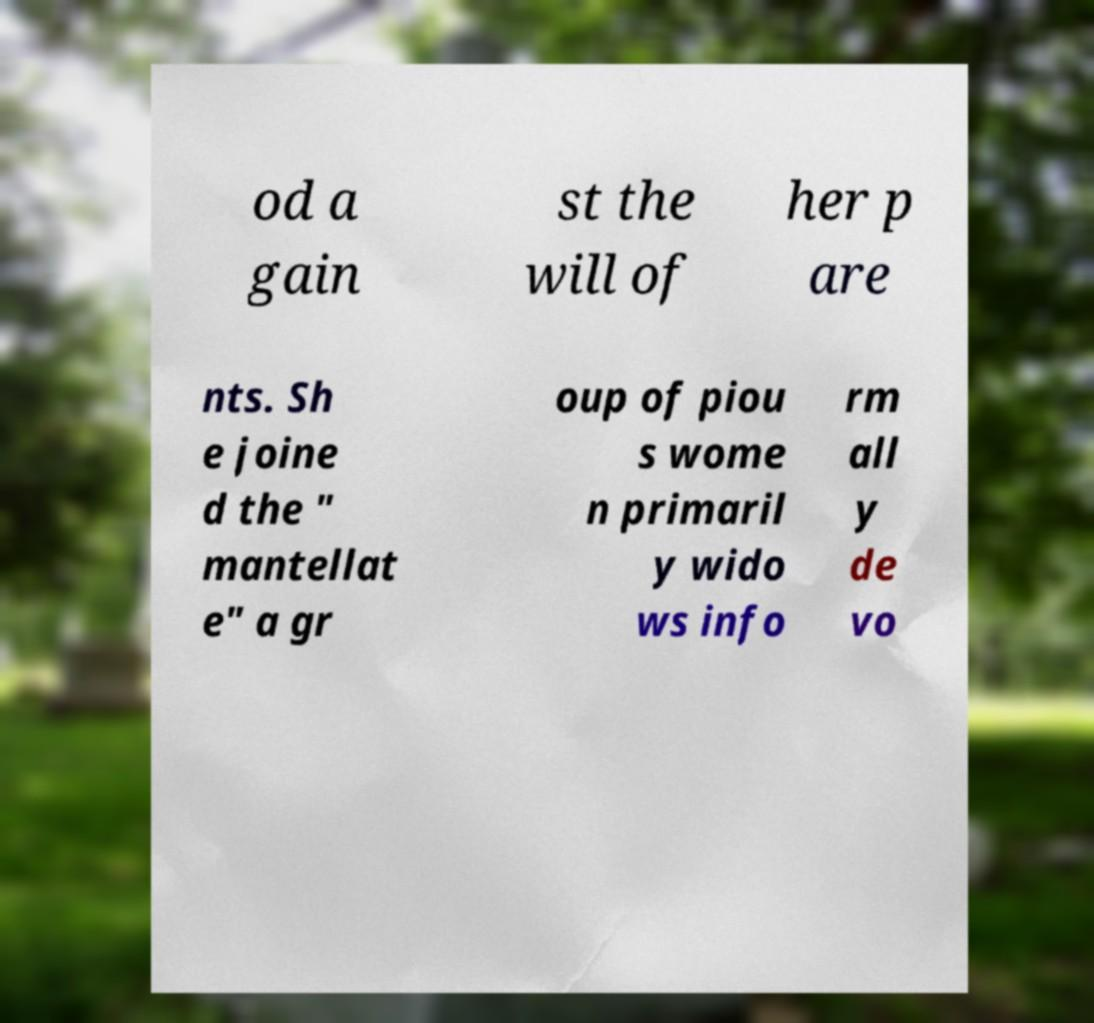I need the written content from this picture converted into text. Can you do that? od a gain st the will of her p are nts. Sh e joine d the " mantellat e" a gr oup of piou s wome n primaril y wido ws info rm all y de vo 